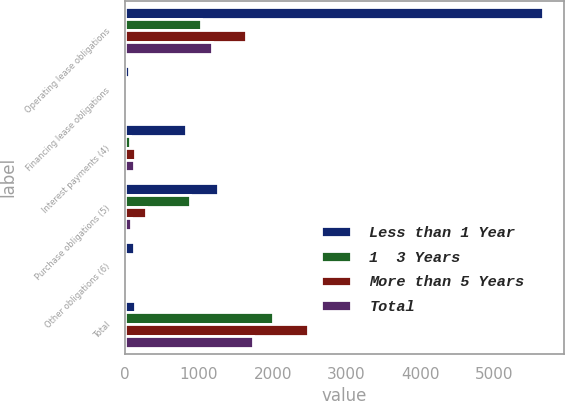Convert chart to OTSL. <chart><loc_0><loc_0><loc_500><loc_500><stacked_bar_chart><ecel><fcel>Operating lease obligations<fcel>Financing lease obligations<fcel>Interest payments (4)<fcel>Purchase obligations (5)<fcel>Other obligations (6)<fcel>Total<nl><fcel>Less than 1 Year<fcel>5669.5<fcel>47.1<fcel>821.2<fcel>1257.1<fcel>122.7<fcel>130.6<nl><fcel>1  3 Years<fcel>1032.4<fcel>3.2<fcel>67.9<fcel>884<fcel>19.2<fcel>2006.7<nl><fcel>More than 5 Years<fcel>1632.3<fcel>6.4<fcel>130.6<fcel>284.7<fcel>28.3<fcel>2482.3<nl><fcel>Total<fcel>1172.9<fcel>6.4<fcel>118.4<fcel>76<fcel>13<fcel>1736.7<nl></chart> 